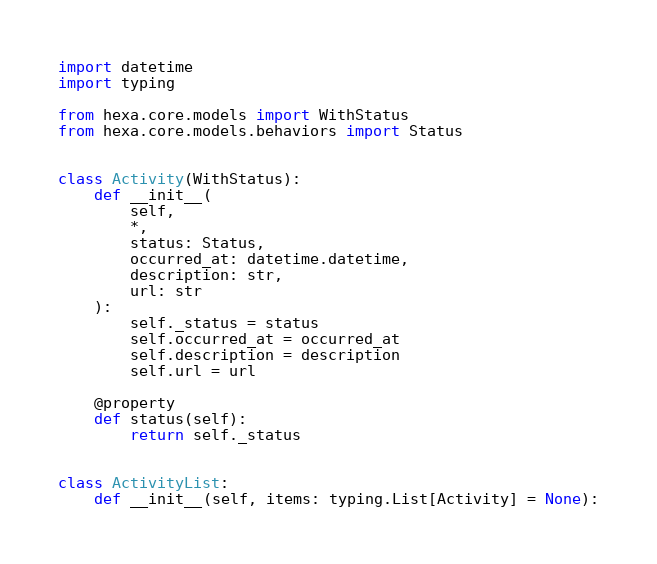Convert code to text. <code><loc_0><loc_0><loc_500><loc_500><_Python_>import datetime
import typing

from hexa.core.models import WithStatus
from hexa.core.models.behaviors import Status


class Activity(WithStatus):
    def __init__(
        self,
        *,
        status: Status,
        occurred_at: datetime.datetime,
        description: str,
        url: str
    ):
        self._status = status
        self.occurred_at = occurred_at
        self.description = description
        self.url = url

    @property
    def status(self):
        return self._status


class ActivityList:
    def __init__(self, items: typing.List[Activity] = None):</code> 